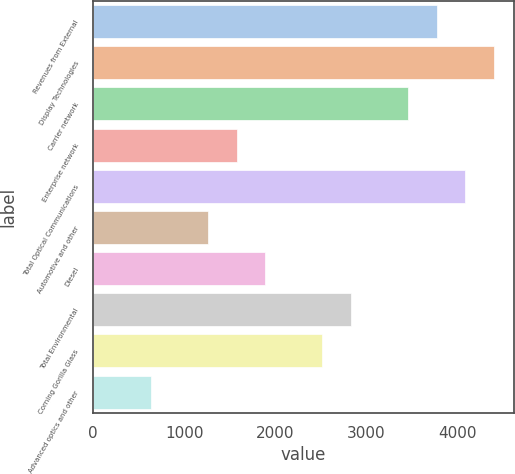<chart> <loc_0><loc_0><loc_500><loc_500><bar_chart><fcel>Revenues from External<fcel>Display Technologies<fcel>Carrier network<fcel>Enterprise network<fcel>Total Optical Communications<fcel>Automotive and other<fcel>Diesel<fcel>Total Environmental<fcel>Corning Gorilla Glass<fcel>Advanced optics and other<nl><fcel>3772.8<fcel>4400.6<fcel>3458.9<fcel>1575.5<fcel>4086.7<fcel>1261.6<fcel>1889.4<fcel>2831.1<fcel>2517.2<fcel>633.8<nl></chart> 